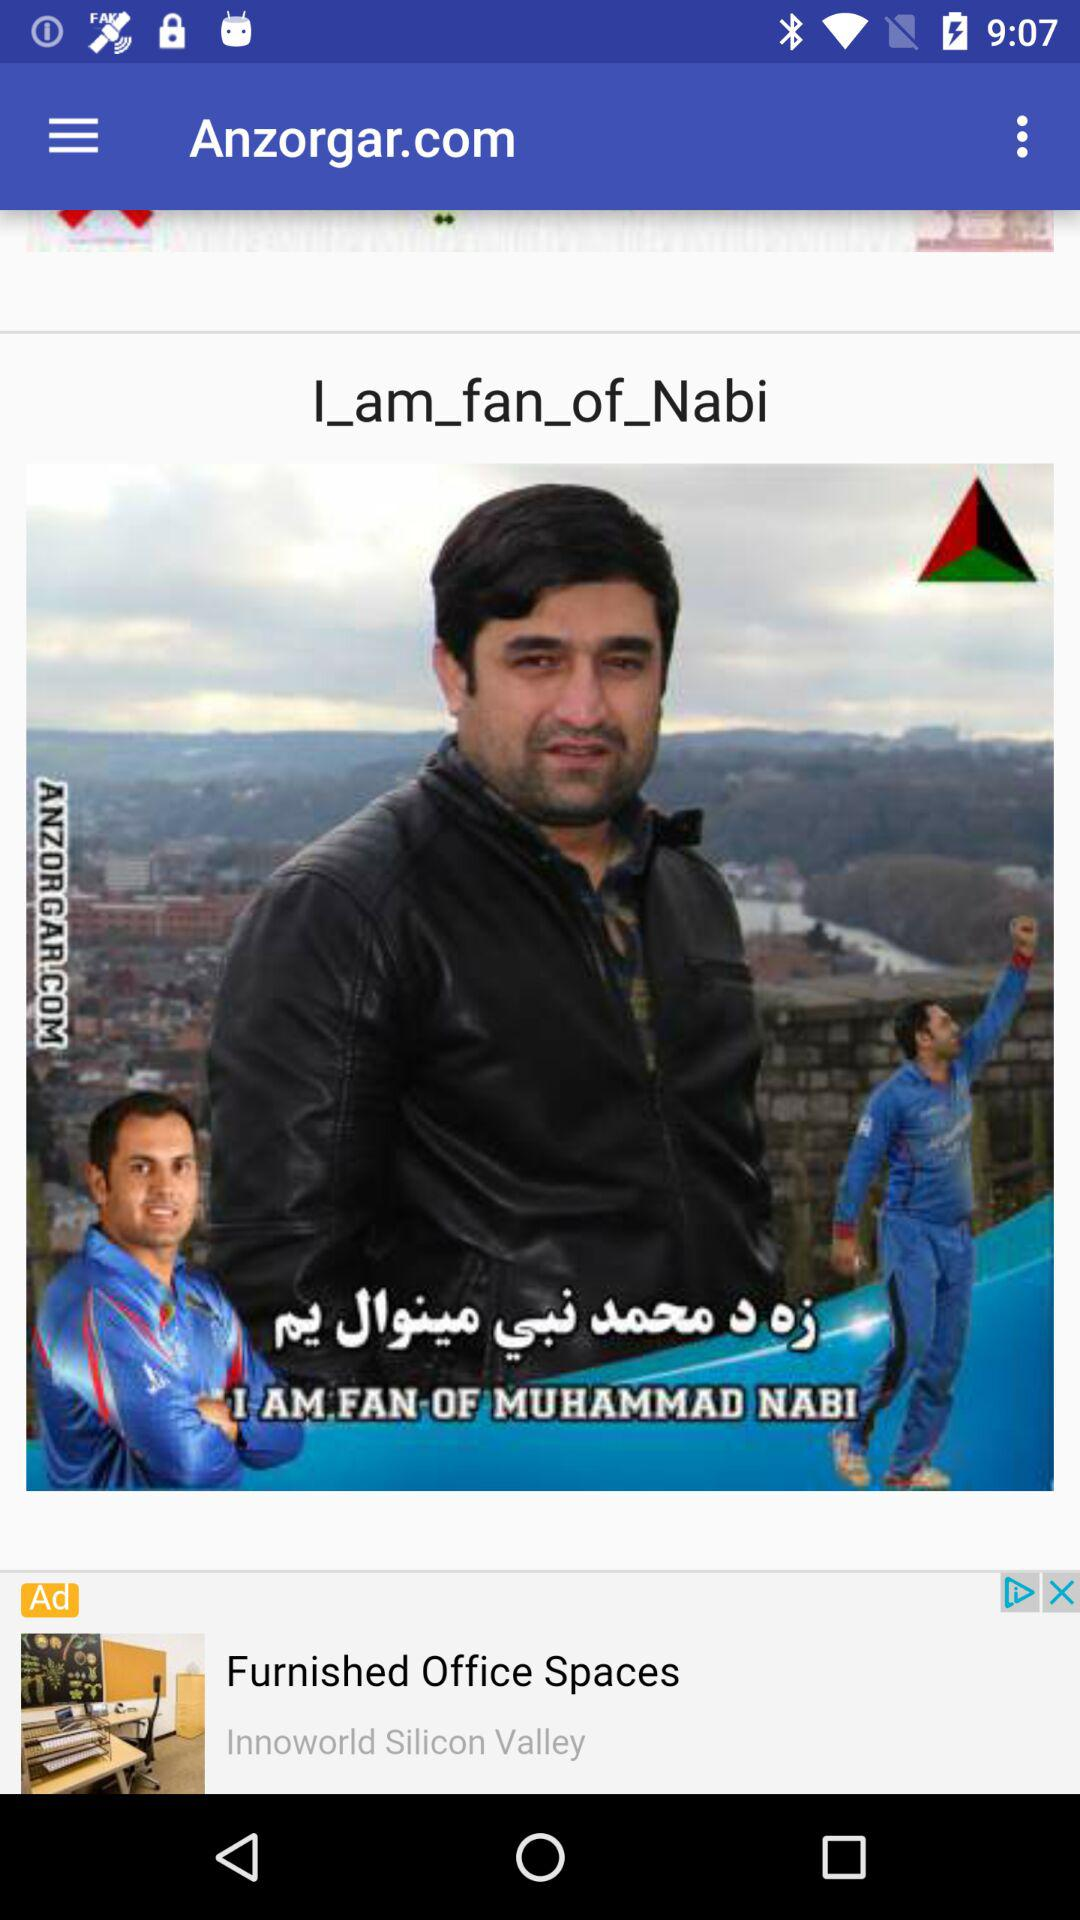What is the application name? The application name is "Anzorgar.com". 